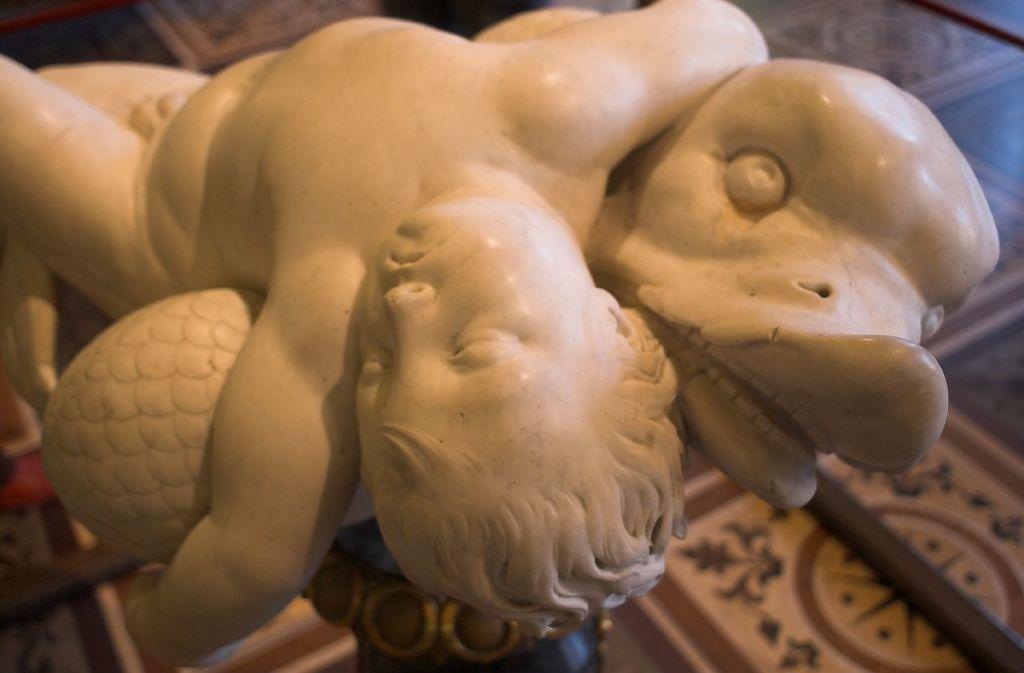Please provide a concise description of this image. In the center of the image there is a depiction of a boy and a animal. 